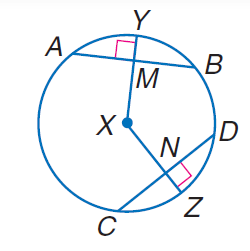Answer the mathemtical geometry problem and directly provide the correct option letter.
Question: In \odot X, A B = 30, C D = 30, and m \widehat C Z = 40. Find m \widehat D Z.
Choices: A: 30 B: 40 C: 60 D: 80 B 